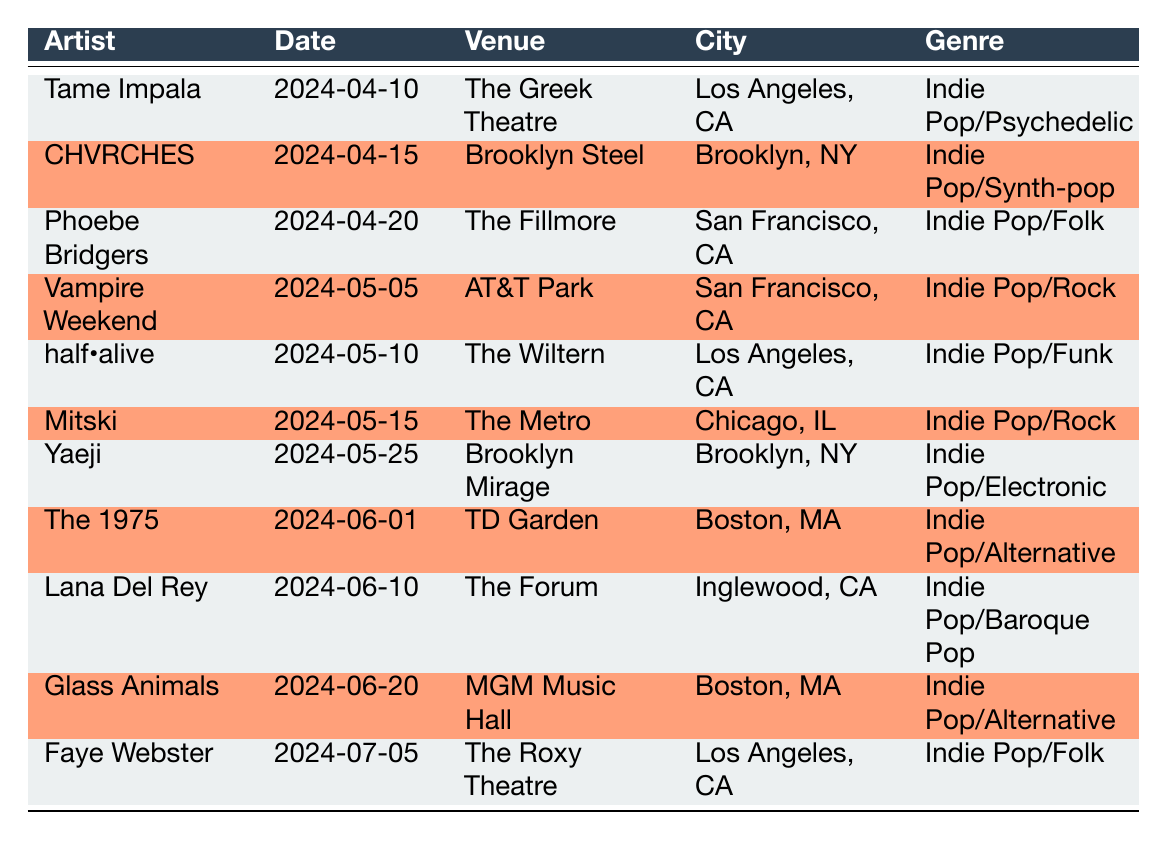What is the date of Tame Impala's concert? The table shows that Tame Impala is scheduled to perform on April 10, 2024. This information is directly found in the 'date' column corresponding to Tame Impala in the table.
Answer: April 10, 2024 Which venue is hosting the concert for Phoebe Bridgers? According to the table, Phoebe Bridgers will perform at The Fillmore. This is found in the 'venue' column associated with Phoebe Bridgers.
Answer: The Fillmore Are there any concerts scheduled in Boston, MA? Yes, the table lists two concerts in Boston, MA: The 1975 at TD Garden on June 1, 2024, and Glass Animals at MGM Music Hall on June 20, 2024. This is checked by looking for 'Boston, MA' in the 'city' column.
Answer: Yes How many concerts are happening in Los Angeles, CA? There are three concerts in Los Angeles, CA: Tame Impala on April 10, half•alive on May 10, and Faye Webster on July 5. We count the entries associated with Los Angeles, CA in the 'city' column.
Answer: 3 Which artist is performing on the latest date according to the table? The latest concert date listed is July 5, 2024, when Faye Webster will be performing. This is determined by checking the 'date' column for the maximum date value.
Answer: Faye Webster Is there a concert by a female artist in May 2024? Yes, Phoebe Bridgers and Mitski, both of whom are female artists, have concerts scheduled in May 2024. This is verified by checking the 'artist' column for female names and their corresponding dates in May.
Answer: Yes Which artist will perform in Brooklyn, NY? CHVRCHES is scheduled to perform at Brooklyn Steel in Brooklyn, NY on April 15, 2024, and also Yaeji at Brooklyn Mirage on May 25, 2024. This is confirmed by reviewing the 'city' and 'artist' columns for Brooklyn, NY.
Answer: CHVRCHES, Yaeji How many unique genres are represented in the concert list? The unique genres include Indie Pop/Psychedelic, Indie Pop/Synth-pop, Indie Pop/Folk, Indie Pop/Rock, Indie Pop/Funk, Indie Pop/Electronic, Indie Pop/Alternative, and Indie Pop/Baroque Pop. There are 8 unique genres identified by listing each genre mentioned in the 'genre' column without repetition.
Answer: 8 Which concert is the first one scheduled in San Francisco, CA? The first concert in San Francisco, CA is by Phoebe Bridgers at The Fillmore on April 20, 2024. This can be found by sorting the 'date' for San Francisco and finding the earliest one.
Answer: Phoebe Bridgers at The Fillmore on April 20, 2024 